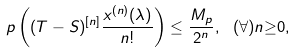<formula> <loc_0><loc_0><loc_500><loc_500>p \left ( ( T - S ) ^ { \left [ n \right ] } \frac { x ^ { ( n ) } ( \lambda ) } { n ! } \right ) \leq \frac { M _ { p } } { 2 ^ { n } } , \text { } ( \forall ) n \mathbb { \geq } 0 ,</formula> 